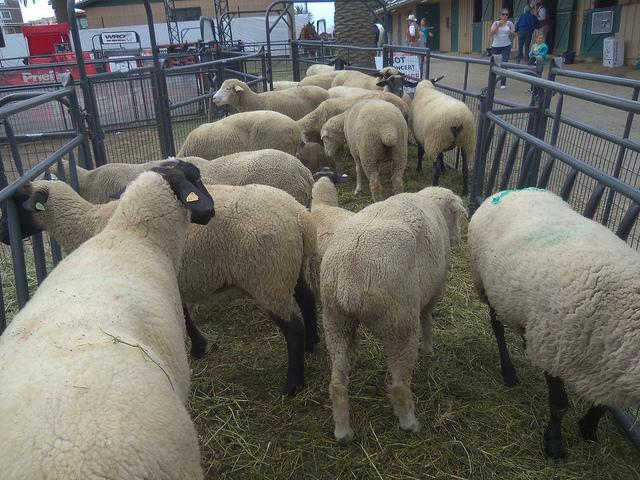What feature do these animals have?

Choices:
A) wool
B) tusks
C) wings
D) antlers wool 